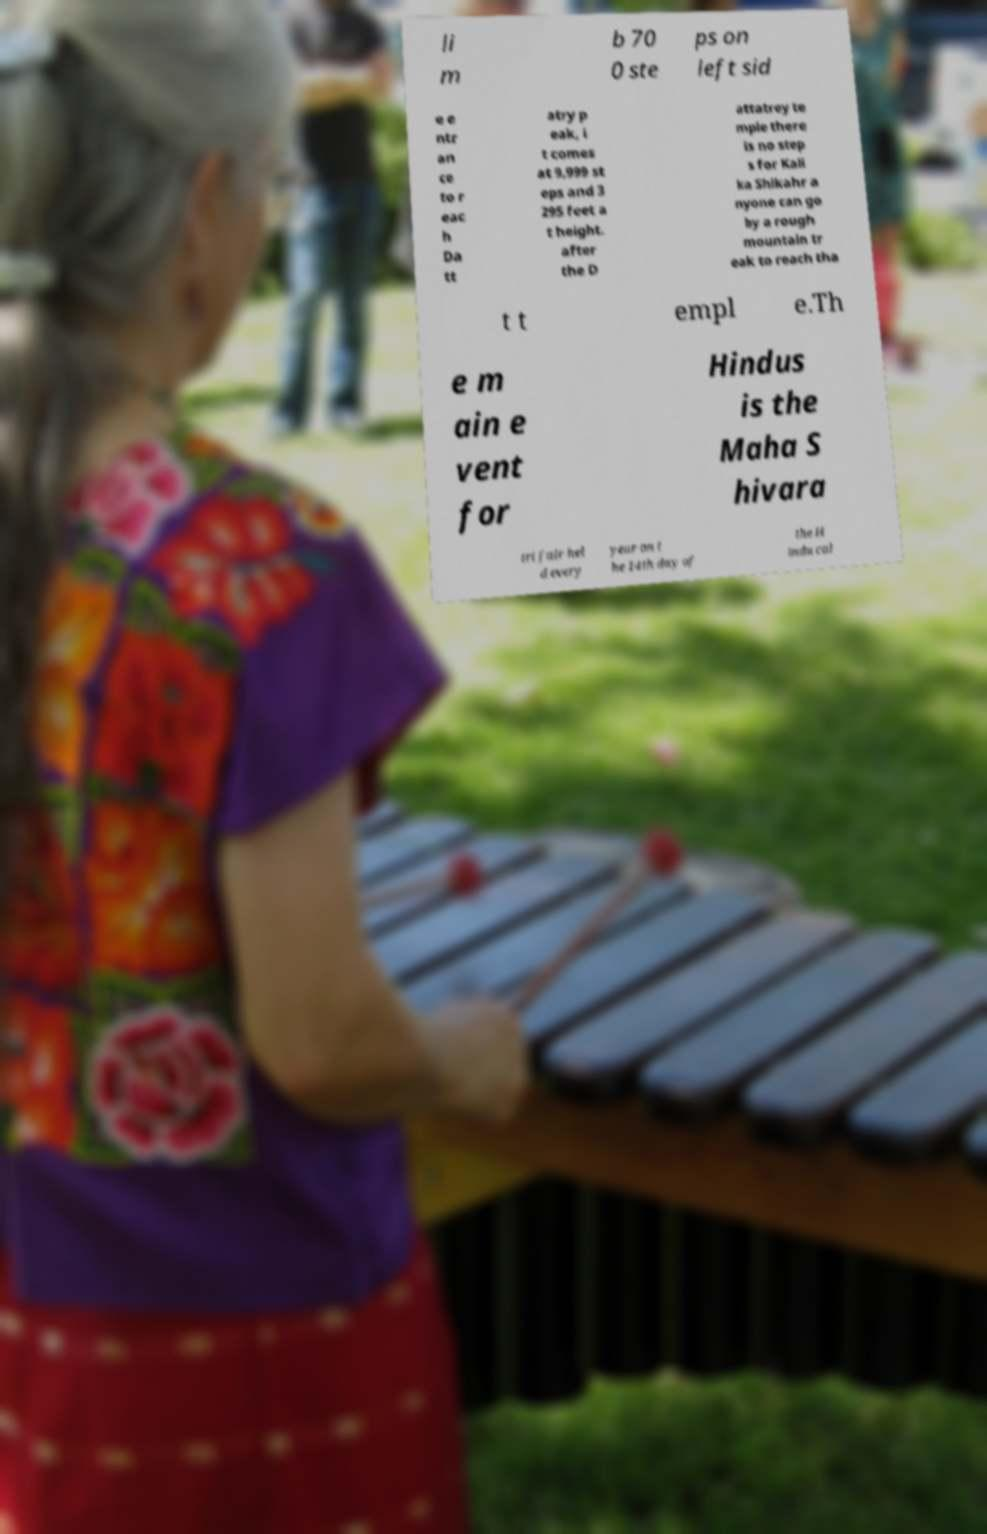There's text embedded in this image that I need extracted. Can you transcribe it verbatim? li m b 70 0 ste ps on left sid e e ntr an ce to r eac h Da tt atry p eak, i t comes at 9,999 st eps and 3 295 feet a t height. after the D attatrey te mple there is no step s for Kali ka Shikahr a nyone can go by a rough mountain tr eak to reach tha t t empl e.Th e m ain e vent for Hindus is the Maha S hivara tri fair hel d every year on t he 14th day of the H indu cal 